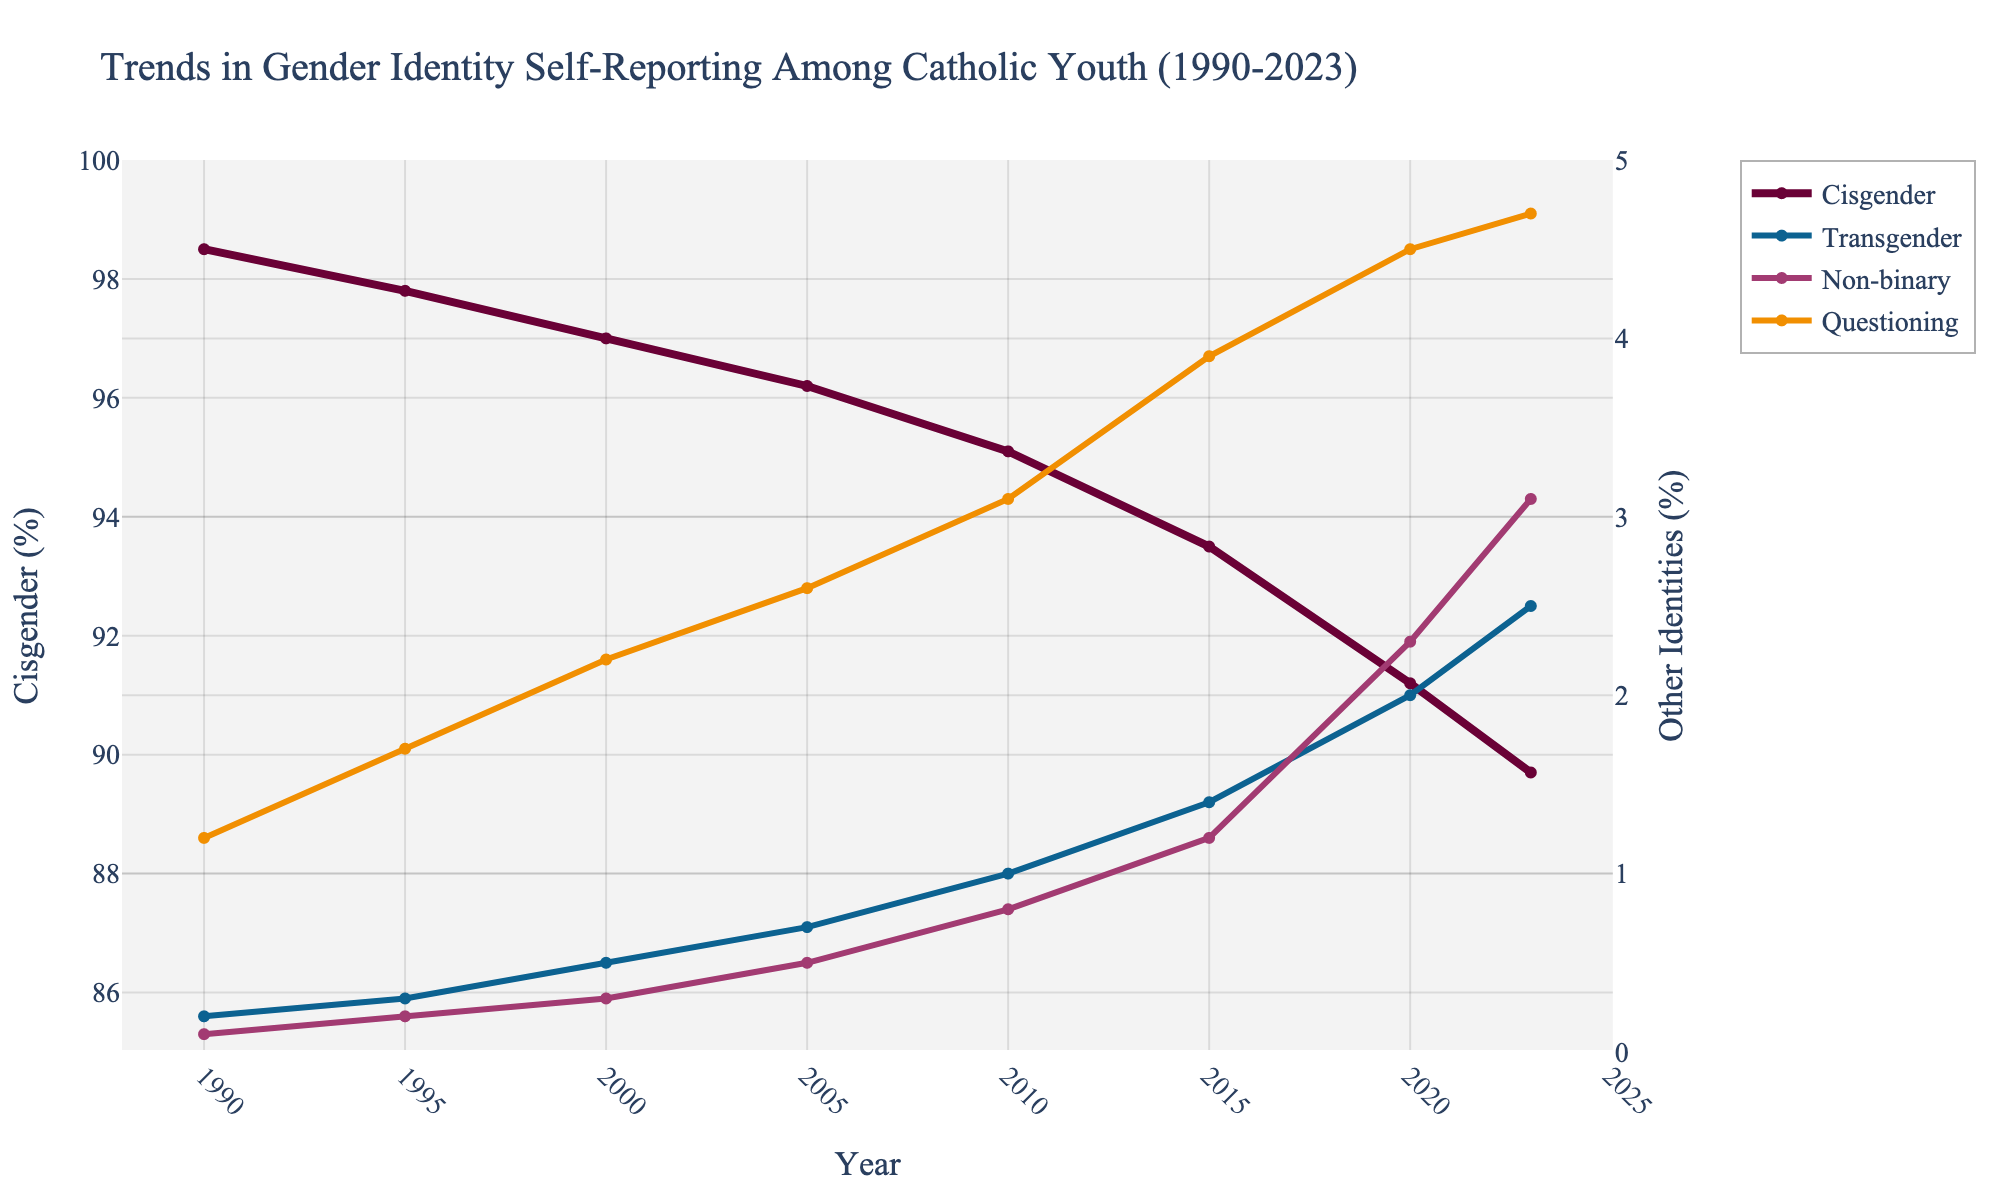What was the percentage increase in the proportion of transgender youth from 1990 to 2023? The percentage of transgender youth in 1990 was 0.2%, and in 2023 it was 2.5%. To find the increase, subtract the 1990 value from the 2023 value: 2.5% - 0.2% = 2.3%.
Answer: 2.3% Which year saw the largest percentage of questioning youth, and what was that percentage? By examining the line chart, the highest percentage of questioning youth is in 2023, with a value of 4.7%.
Answer: 2023, 4.7% How does the percentage of non-binary youth in 2015 compare with that in 2020? In 2015, the percentage of non-binary youth was 1.2%, whereas in 2020 it was 2.3%. The percentage of non-binary youth has increased from 2015 to 2020.
Answer: Increased What is the difference in the percentage of cisgender youth between 2000 and 2023? The percentage of cisgender youth in 2000 was 97.0%, and in 2023 it was 89.7%. To find the difference: 97.0% - 89.7% = 7.3%.
Answer: 7.3% What trend can you observe in the proportion of cisgender youth from 1990 to 2023? The line representing cisgender youth shows a clear downward trend from 1990, starting at 98.5%, to 2023, ending at 89.7%. This indicates a steady decline over the years.
Answer: Downward trend Considering the trends from 1990 to 2023, which gender identity saw the most significant relative change in reporting percentage? By comparing the lines, the transgender identity saw the most significant relative change, increasing from 0.2% in 1990 to 2.5% in 2023.
Answer: Transgender What was the combined percentage of non-binary and questioning youth in 2010? In 2010, the percentage of non-binary youth was 0.8%, and the percentage of questioning youth was 3.1%. Adding these together: 0.8% + 3.1% = 3.9%.
Answer: 3.9% How did the proportion of transgender youth change between 1990 and 2005? In 1990, the percentage of transgender youth was 0.2%, and in 2005 it was 0.7%. The change is: 0.7% - 0.2% = 0.5%.
Answer: 0.5% In which year did the percentage of cisgender youth fall below 95% for the first time? By examining the line for cisgender youth, the percentage first falls below 95% in the year 2010.
Answer: 2010 